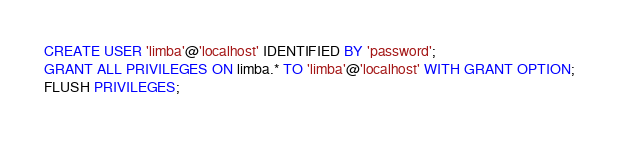<code> <loc_0><loc_0><loc_500><loc_500><_SQL_>CREATE USER 'limba'@'localhost' IDENTIFIED BY 'password';
GRANT ALL PRIVILEGES ON limba.* TO 'limba'@'localhost' WITH GRANT OPTION;
FLUSH PRIVILEGES;</code> 